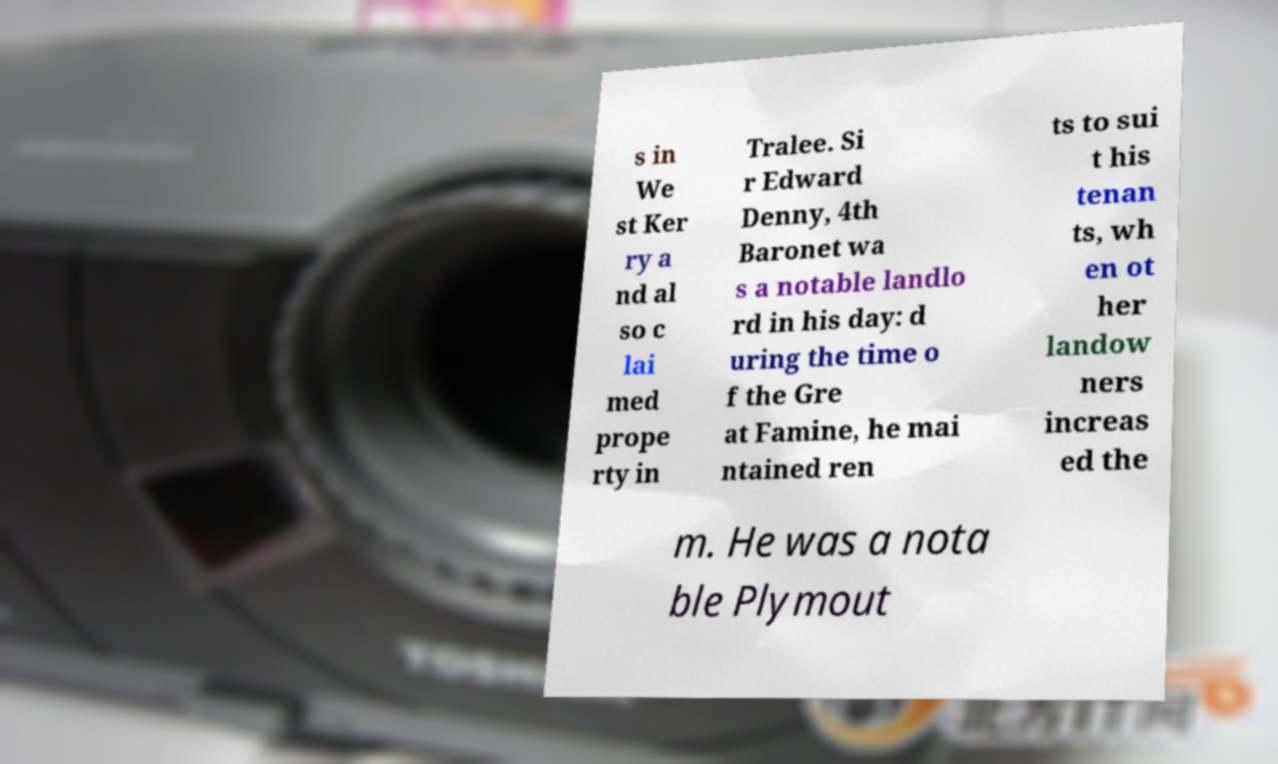Could you assist in decoding the text presented in this image and type it out clearly? s in We st Ker ry a nd al so c lai med prope rty in Tralee. Si r Edward Denny, 4th Baronet wa s a notable landlo rd in his day: d uring the time o f the Gre at Famine, he mai ntained ren ts to sui t his tenan ts, wh en ot her landow ners increas ed the m. He was a nota ble Plymout 